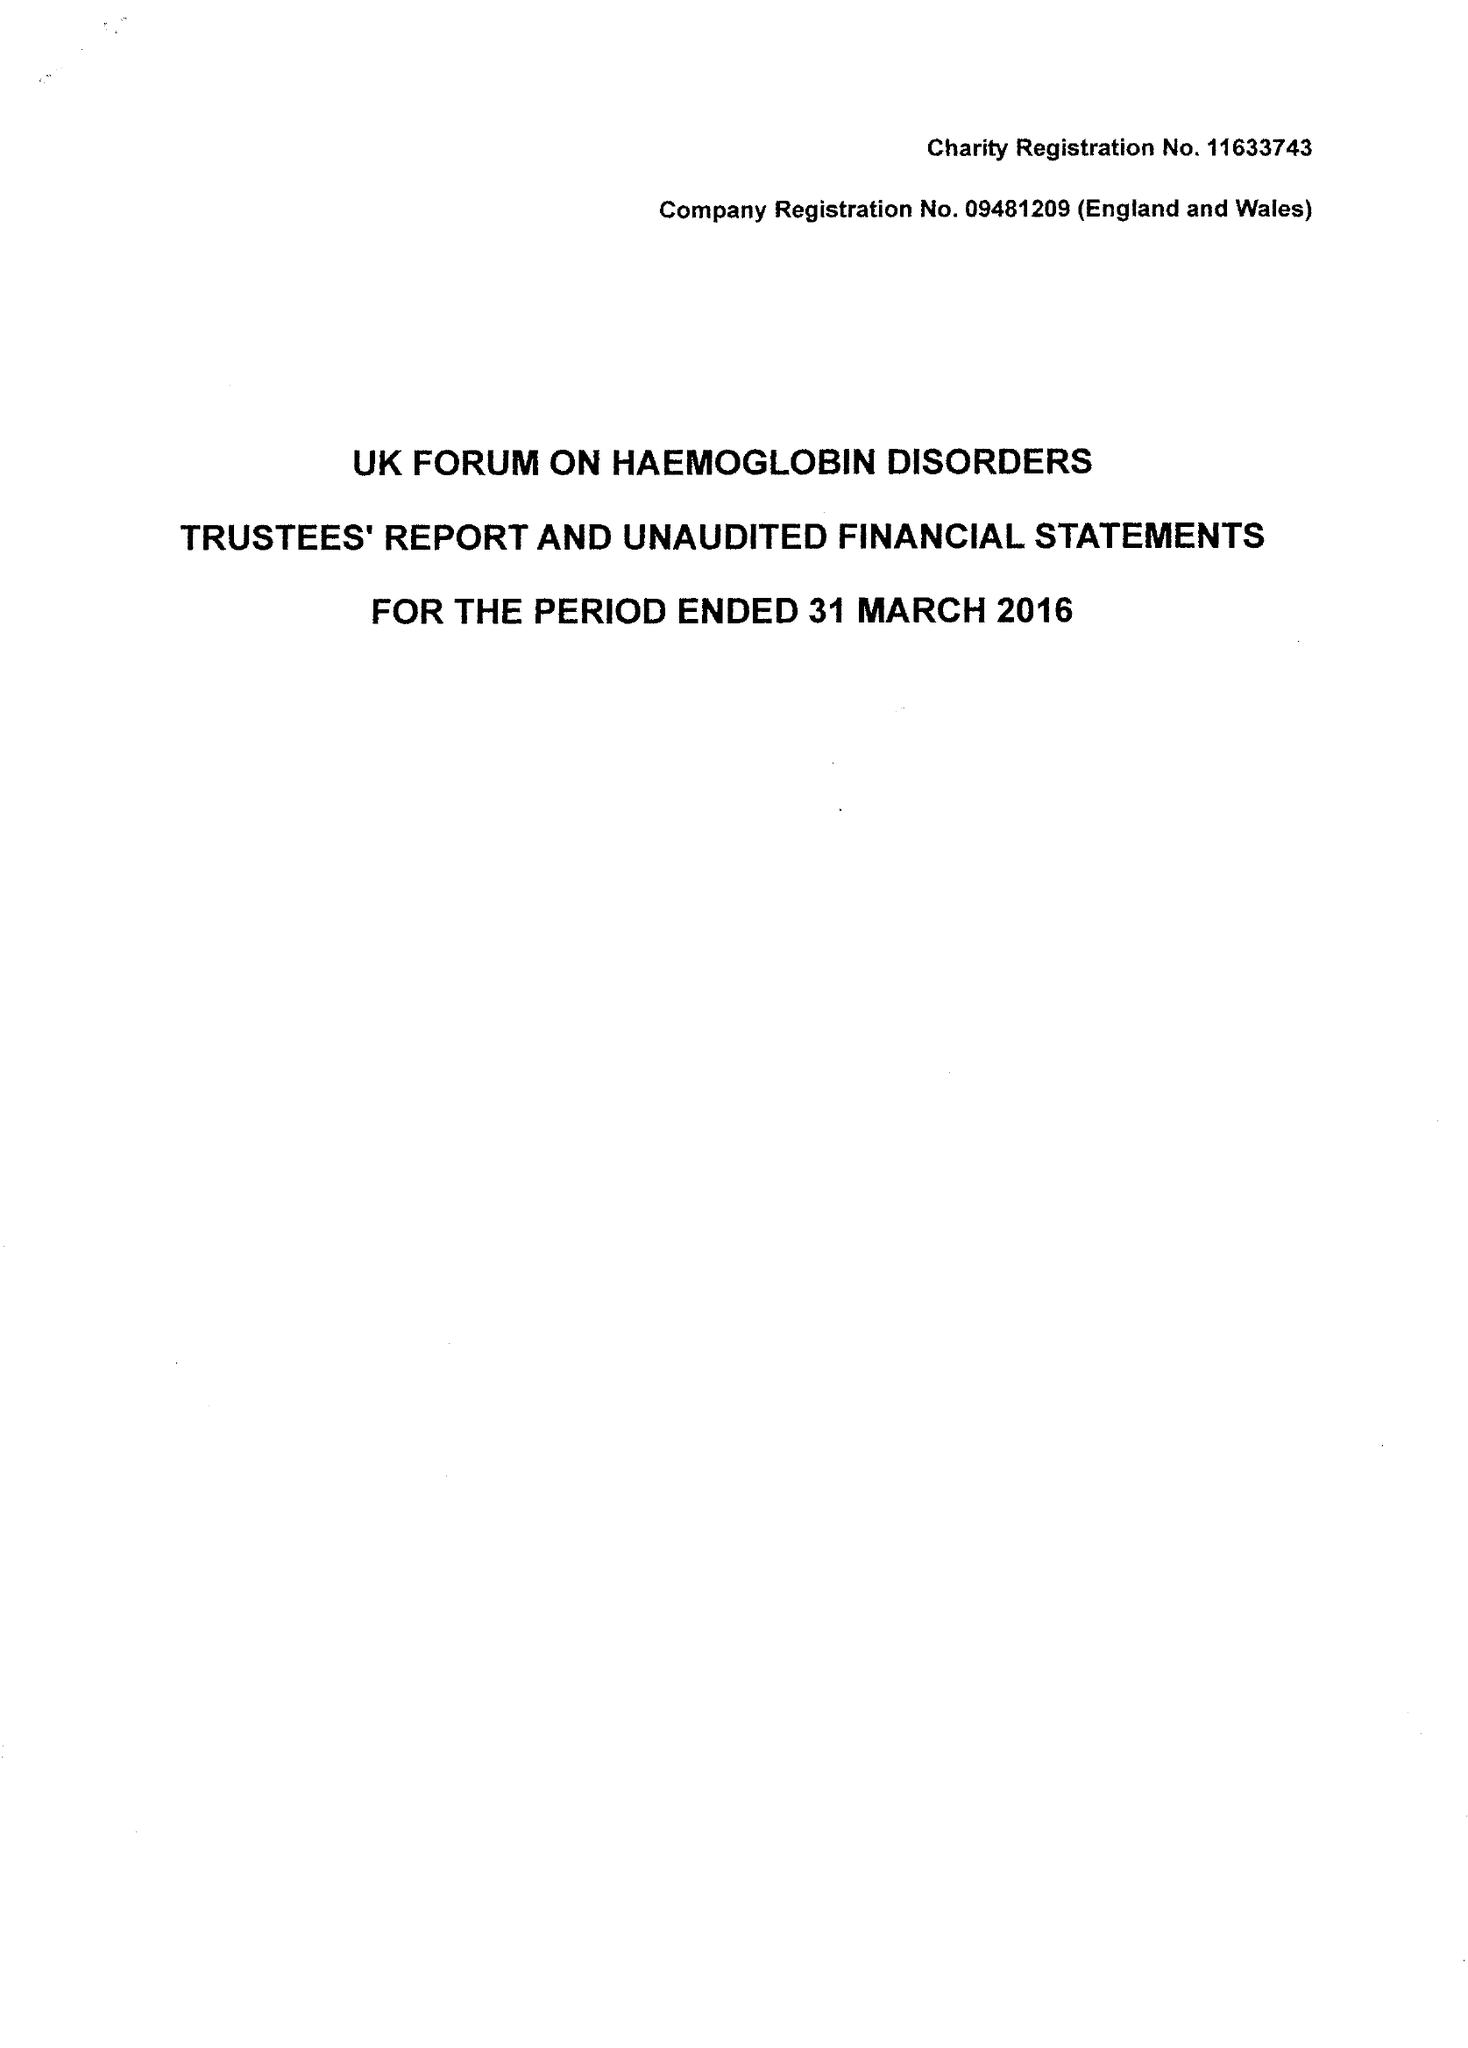What is the value for the charity_number?
Answer the question using a single word or phrase. 1163743 